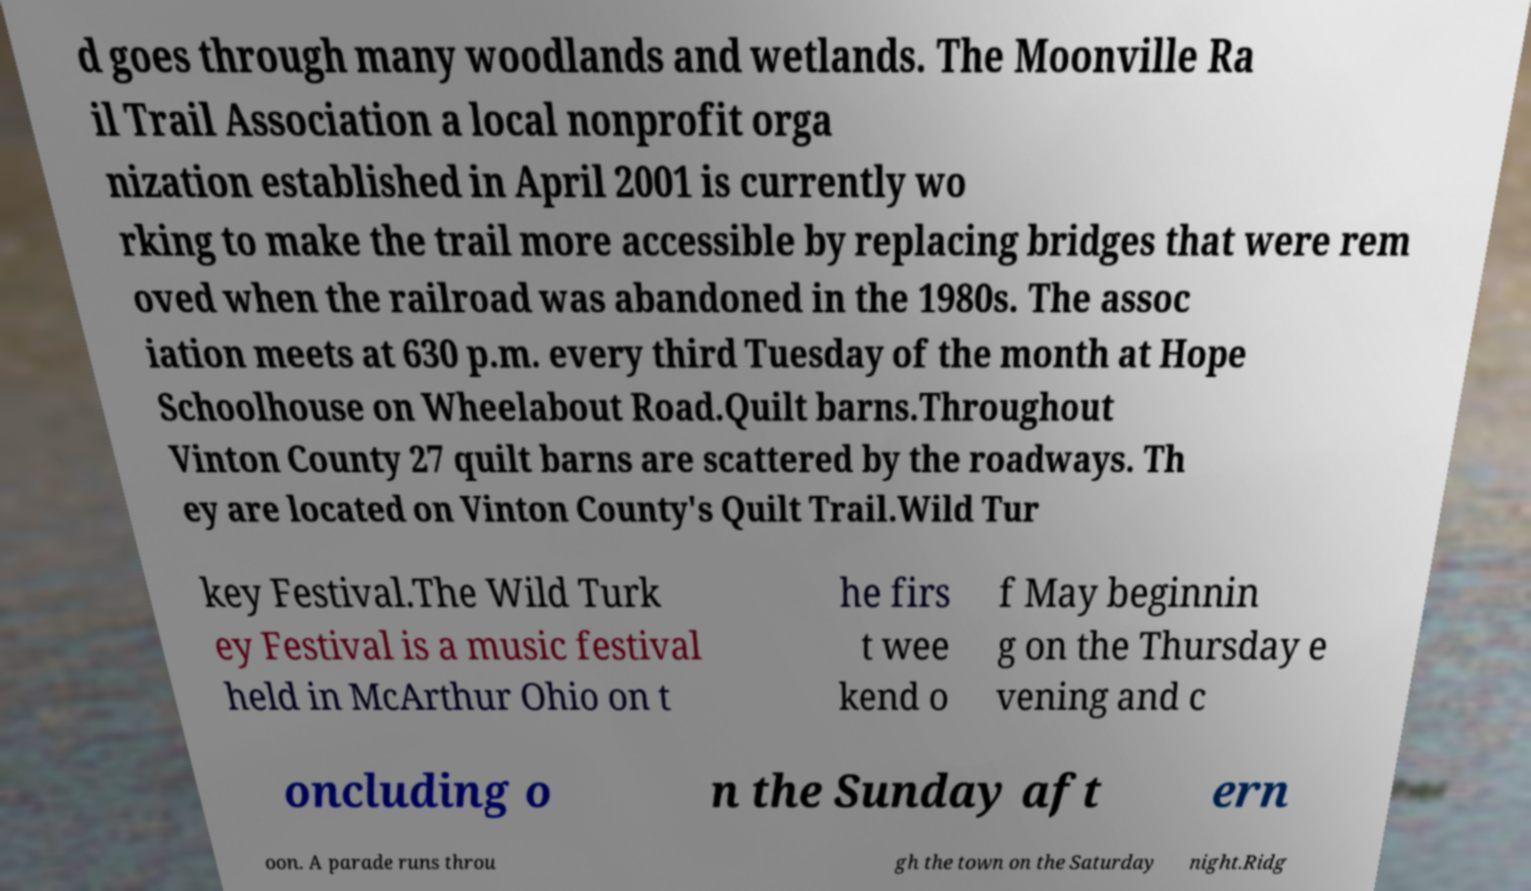Please read and relay the text visible in this image. What does it say? d goes through many woodlands and wetlands. The Moonville Ra il Trail Association a local nonprofit orga nization established in April 2001 is currently wo rking to make the trail more accessible by replacing bridges that were rem oved when the railroad was abandoned in the 1980s. The assoc iation meets at 630 p.m. every third Tuesday of the month at Hope Schoolhouse on Wheelabout Road.Quilt barns.Throughout Vinton County 27 quilt barns are scattered by the roadways. Th ey are located on Vinton County's Quilt Trail.Wild Tur key Festival.The Wild Turk ey Festival is a music festival held in McArthur Ohio on t he firs t wee kend o f May beginnin g on the Thursday e vening and c oncluding o n the Sunday aft ern oon. A parade runs throu gh the town on the Saturday night.Ridg 